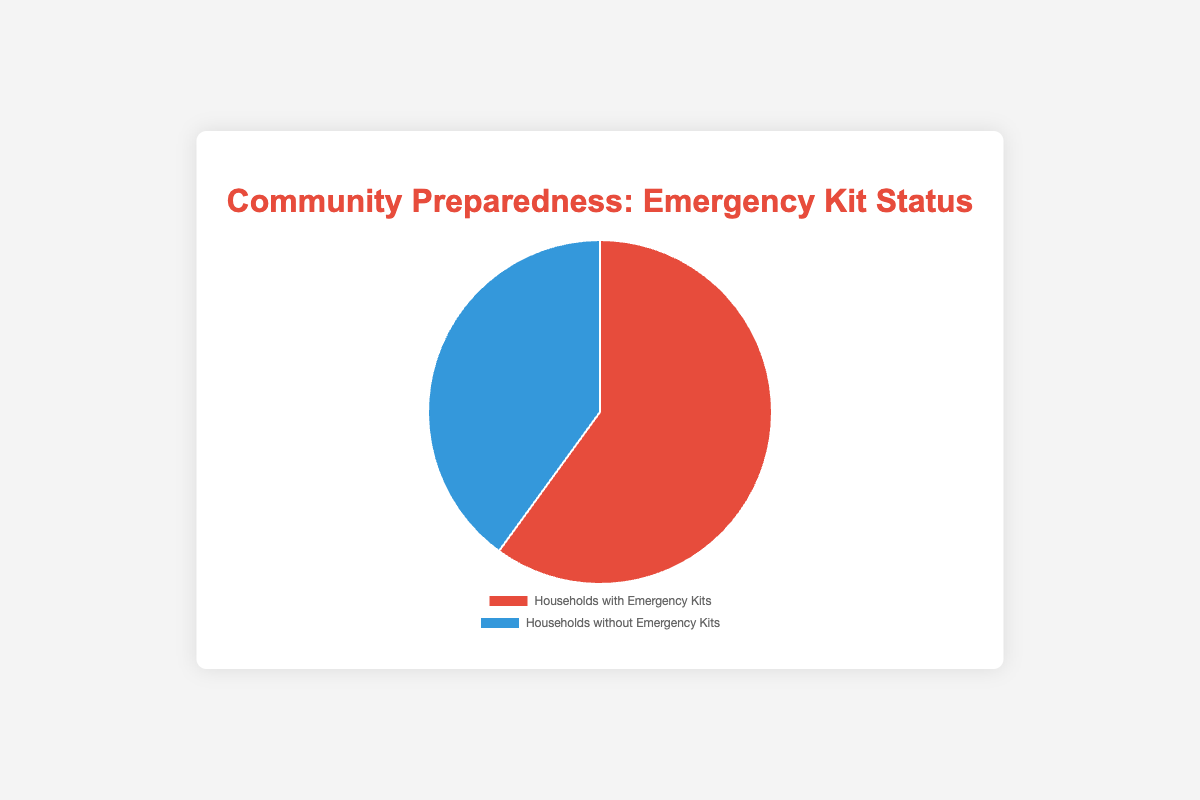What percentage of households have emergency kits? Referencing the figure, the slice representing households with emergency kits is labeled with its percentage.
Answer: 60% Which group is larger: households with emergency kits or those without? According to the graph, households with emergency kits make up 60%, while those without make up 40%. 60% is greater than 40%.
Answer: Households with emergency kits What is the total number of households represented in the chart? Add the number of households with emergency kits (1500) to the number of households without emergency kits (1000). 1500 + 1000 = 2500
Answer: 2500 How many more households have emergency kits compared to those without? Subtract the number of households without emergency kits (1000) from the number of households with them (1500). 1500 - 1000 = 500
Answer: 500 What color represents households without emergency kits? Look at the legend on the pie chart; the segment for households without emergency kits will have its color specified. The color associated with this category is blue.
Answer: Blue What fraction of households lack emergency kits? The percentage of households without emergency kits is shown on the pie chart as 40%. To convert this to a fraction, divide by 100: 40/100 = 2/5.
Answer: 2/5 If 300 households obtain emergency kits, what will be the new percentage of households with kits? Adding 300 to the current 1500 households with kits gives 1800 households. The total number of households remains 2500. Therefore, the new percentage is (1800/2500) * 100. (1800/2500) * 100 = 72%.
Answer: 72% What is the ratio of households with emergency kits to those without? Divide the number of households with emergency kits (1500) by the number of households without them (1000). 1500/1000 = 1.5, which simplifies to 3:2.
Answer: 3:2 